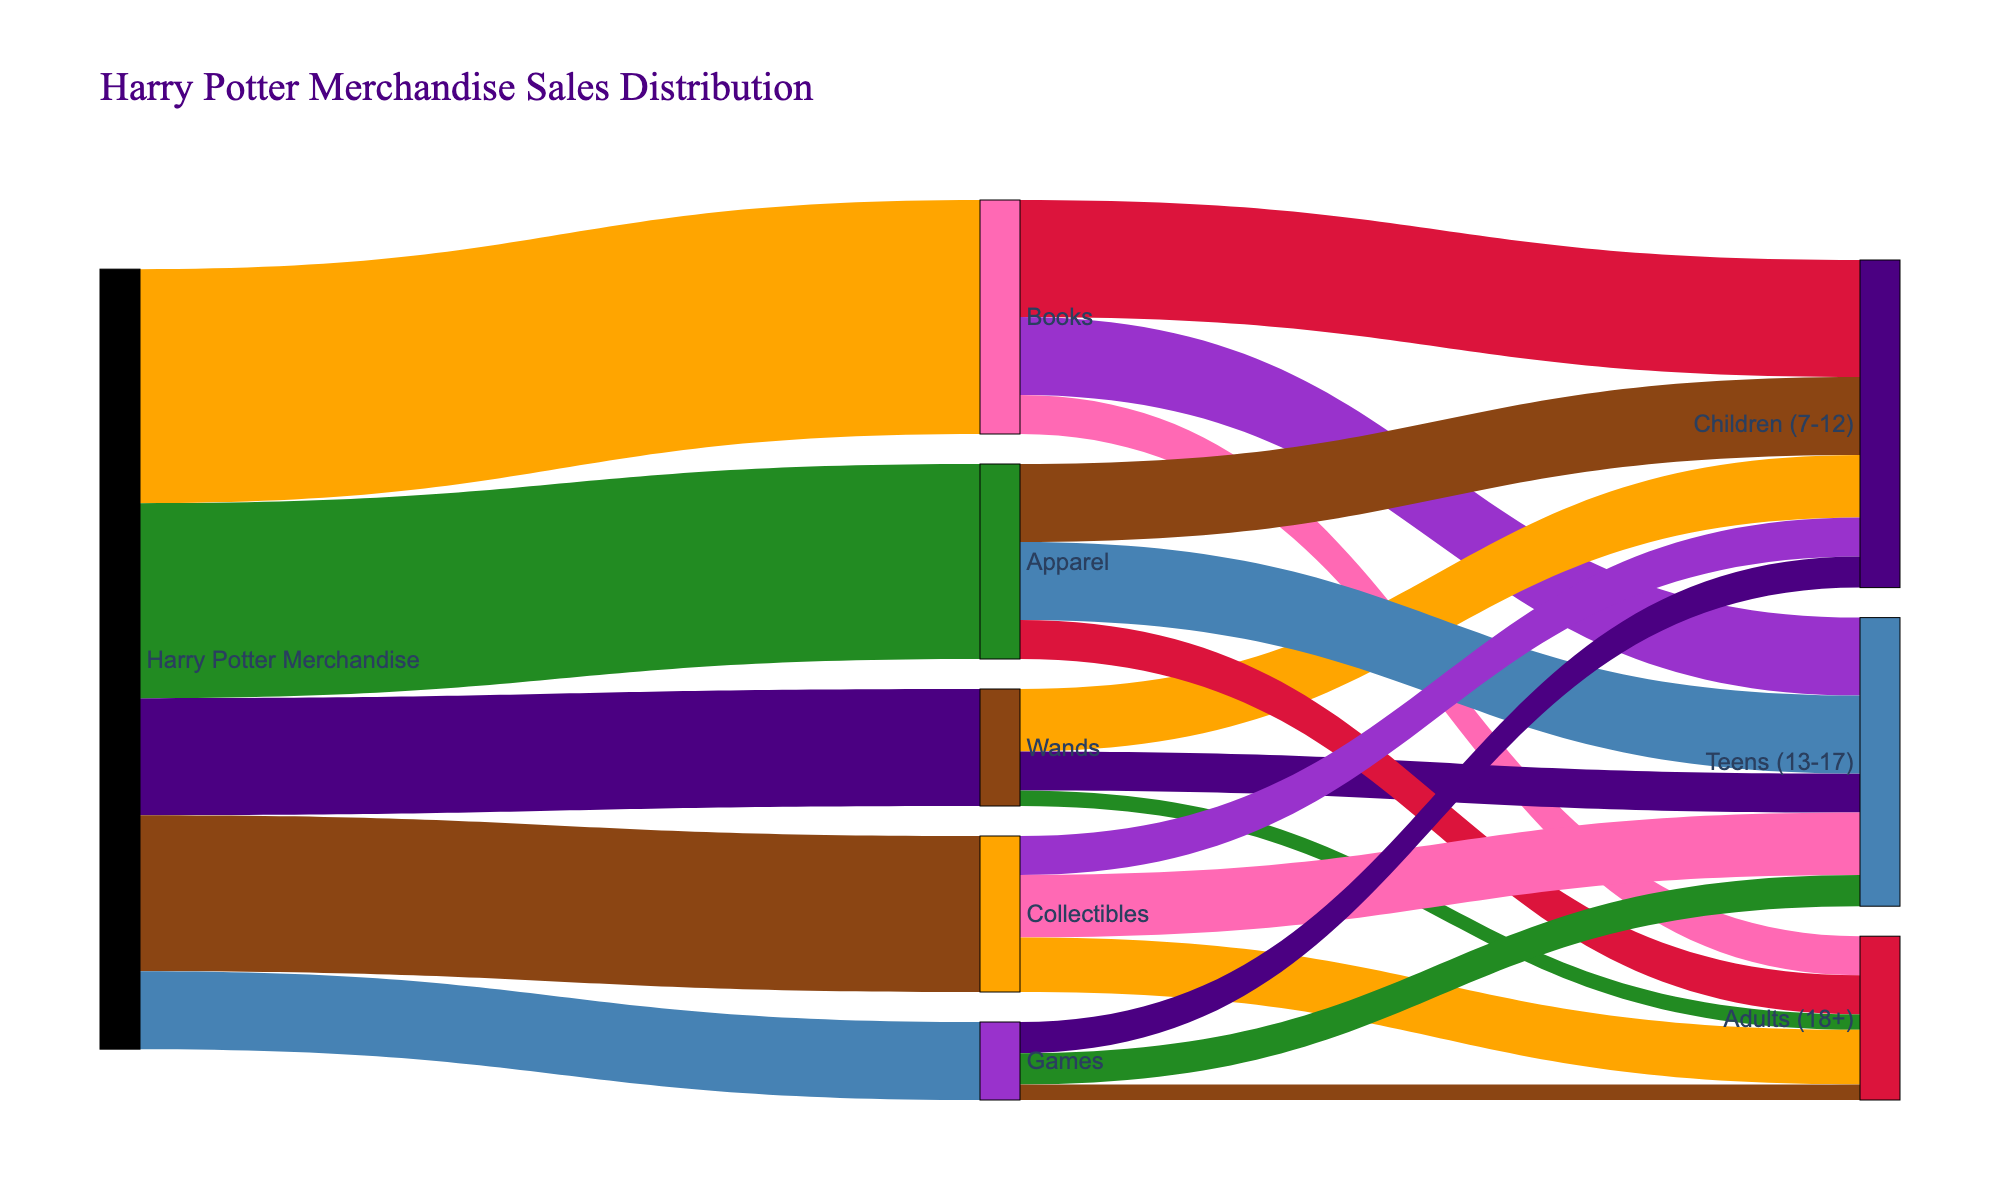What is the title of the Sankey diagram? The title is prominently displayed at the top of the figure in a larger and different font style and color compared to the other texts.
Answer: Harry Potter Merchandise Sales Distribution Which product type has the highest sales value? By following the width of the flows originating from "Harry Potter Merchandise," the widest flow leads to "Books," indicating the highest sales value.
Answer: Books How many units of Apparel are sold to Adults (18+)? Find the flow that goes from "Apparel" to "Adults (18+)" and check its width. The flow represents the sales value.
Answer: 5 What is the total sales value for Collectibles? Sum the values of all the sales categories under "Collectibles" by looking at the flows: 5 (Children) + 8 (Teens) + 7 (Adults).
Answer: 20 How do sales values of Wands and Games to Teens (13-17) compare? Compare the flows from "Wands" to "Teens" and "Games" to "Teens". The flow from "Wands" to "Teens" is narrower than "Games" to "Teens".
Answer: Wands: 5, Games: 4 Which target age group has the highest sales value for Books? Check each flow from "Books" to the respective age groups and see which is widest. The flow to "Children (7-12)" is widest compared to others.
Answer: Children (7-12) What is the total sales value of Harry Potter Merchandise going to Children (7-12)? Sum all the values heading from different product types to "Children (7-12)": 15 (Books) + 8 (Wands) + 10 (Apparel) + 5 (Collectibles) + 4 (Games).
Answer: 42 What is the difference in sales between Apparel and Games? Subtract the total sales value of "Games" from "Apparel": 25 (Apparel) - 10 (Games).
Answer: 15 Which category, Books or Collectibles, has higher sales to Adults (18+)? Compare the flows from "Books" to "Adults" and "Collectibles" to "Adults". The flow from "Collectibles" is wider.
Answer: Collectibles Which product type has the lowest sales value overall? Check the flows originating from "Harry Potter Merchandise" to see which has the smallest width; "Games" has the narrowest flow.
Answer: Games 